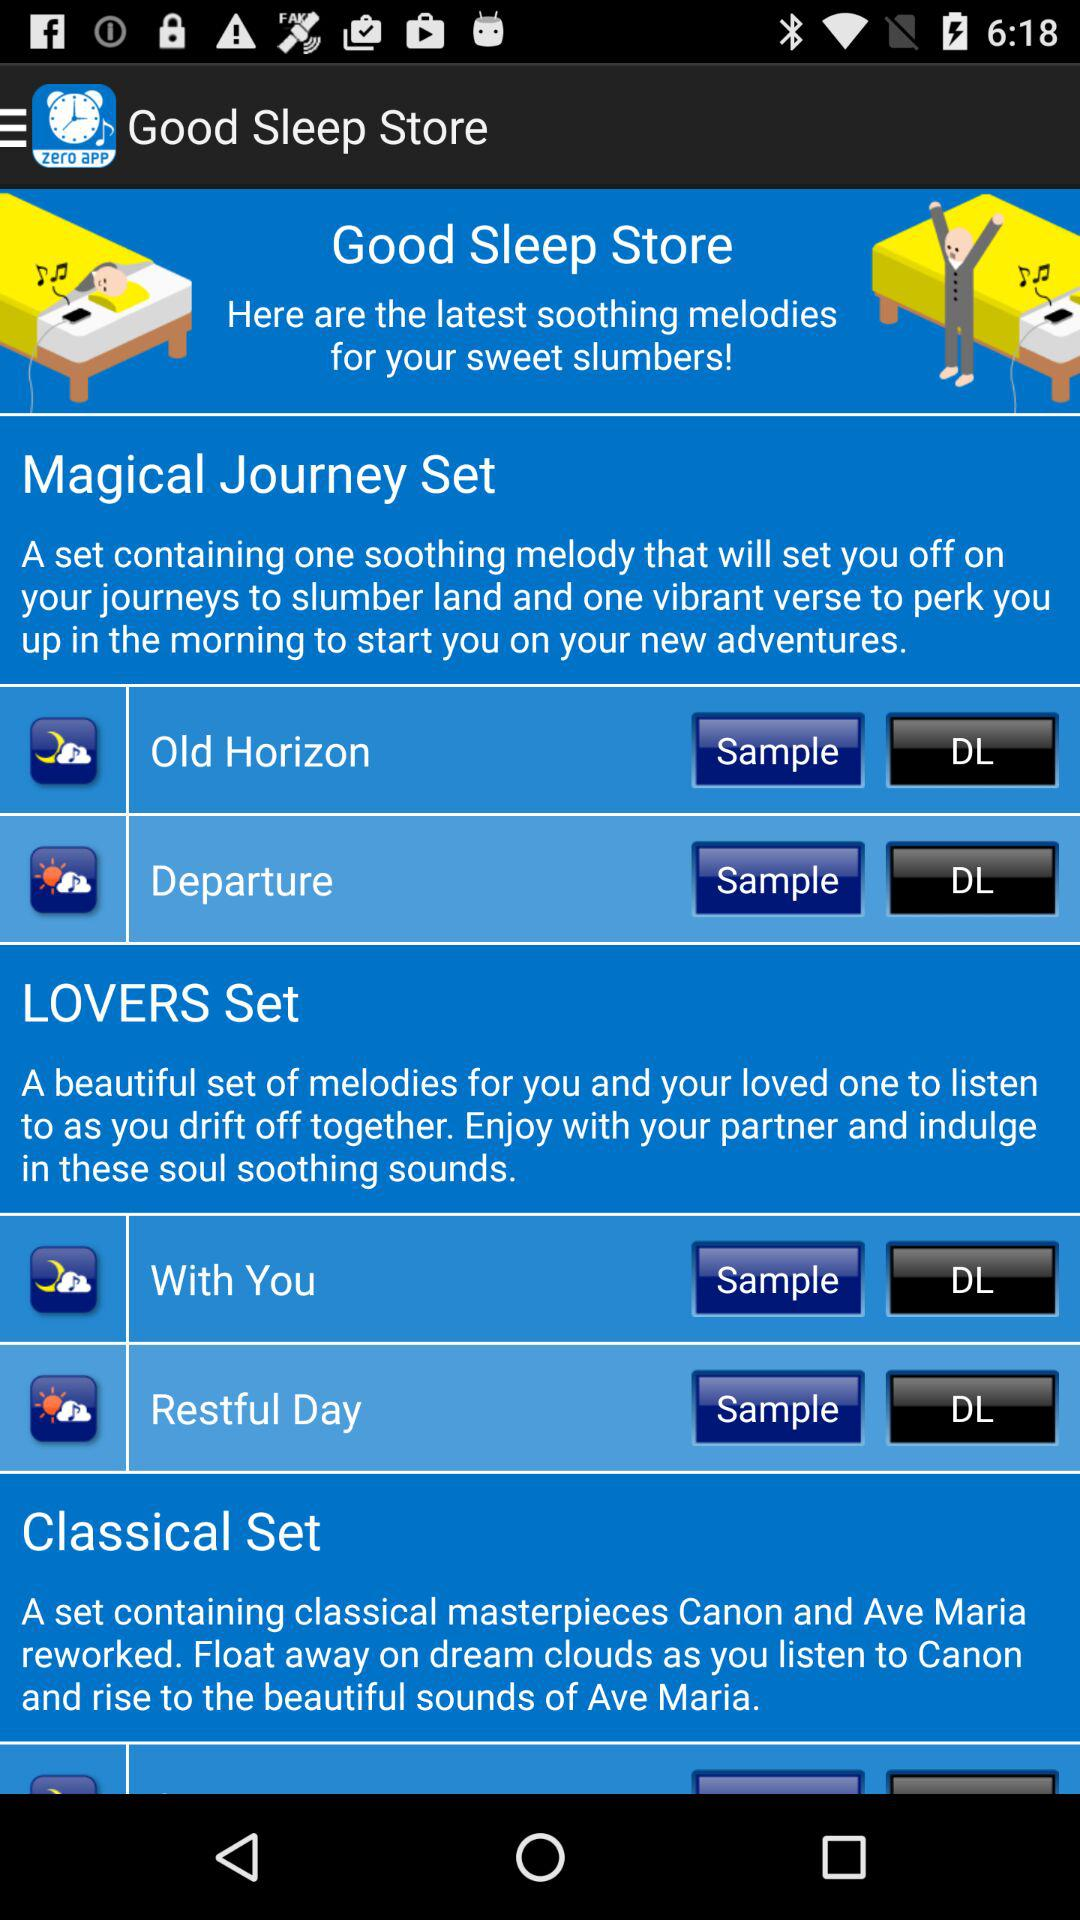Which are the two melodies in the Lover's Journey set? The two melodies in the Lover's Journey set are : "With You" and "Restful Day". 